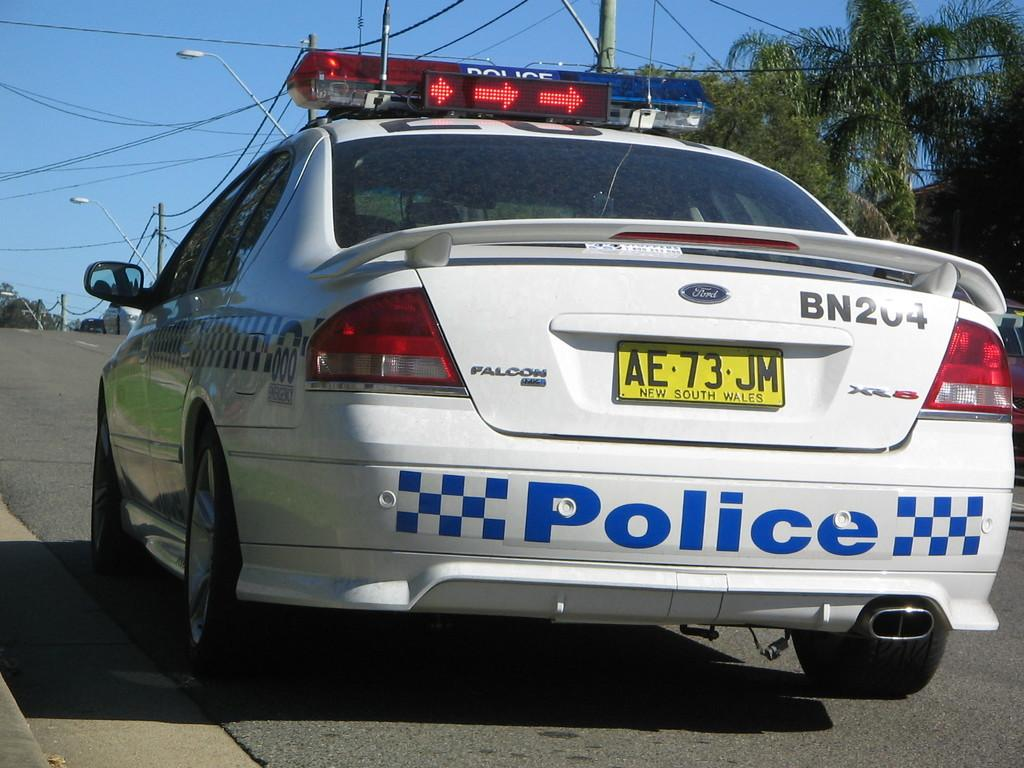What type of vehicle is on the road in the image? There is a white color car on the road in the image. What can be seen in the background of the image? There are poles and trees in the background of the image. What is visible at the top of the image? The sky is visible at the top of the image. What flavor of eggs can be seen in the image? There are no eggs present in the image, so it is not possible to determine their flavor. 